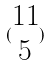<formula> <loc_0><loc_0><loc_500><loc_500>( \begin{matrix} 1 1 \\ 5 \end{matrix} )</formula> 